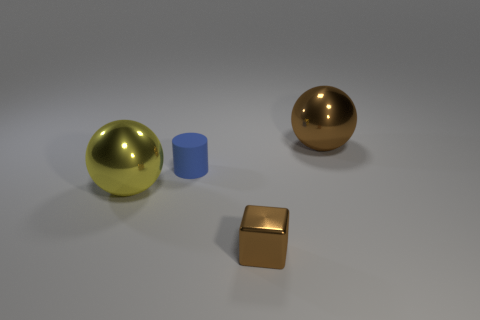Are there more big blue shiny balls than big yellow spheres?
Your answer should be compact. No. What number of other things are the same color as the tiny metal cube?
Your answer should be compact. 1. What number of yellow objects are behind the big ball to the right of the big yellow metal ball?
Provide a succinct answer. 0. There is a brown ball; are there any big yellow shiny balls to the right of it?
Provide a succinct answer. No. What is the shape of the brown shiny object on the right side of the small cube on the right side of the blue cylinder?
Provide a short and direct response. Sphere. Is the number of metal objects that are behind the small blue cylinder less than the number of small blue matte cylinders that are in front of the shiny cube?
Offer a very short reply. No. What color is the other metal object that is the same shape as the big yellow metallic thing?
Offer a very short reply. Brown. How many objects are on the right side of the blue object and in front of the tiny matte cylinder?
Ensure brevity in your answer.  1. Is the number of big yellow objects behind the brown sphere greater than the number of objects that are to the right of the small brown cube?
Offer a terse response. No. The brown ball is what size?
Your answer should be very brief. Large. 